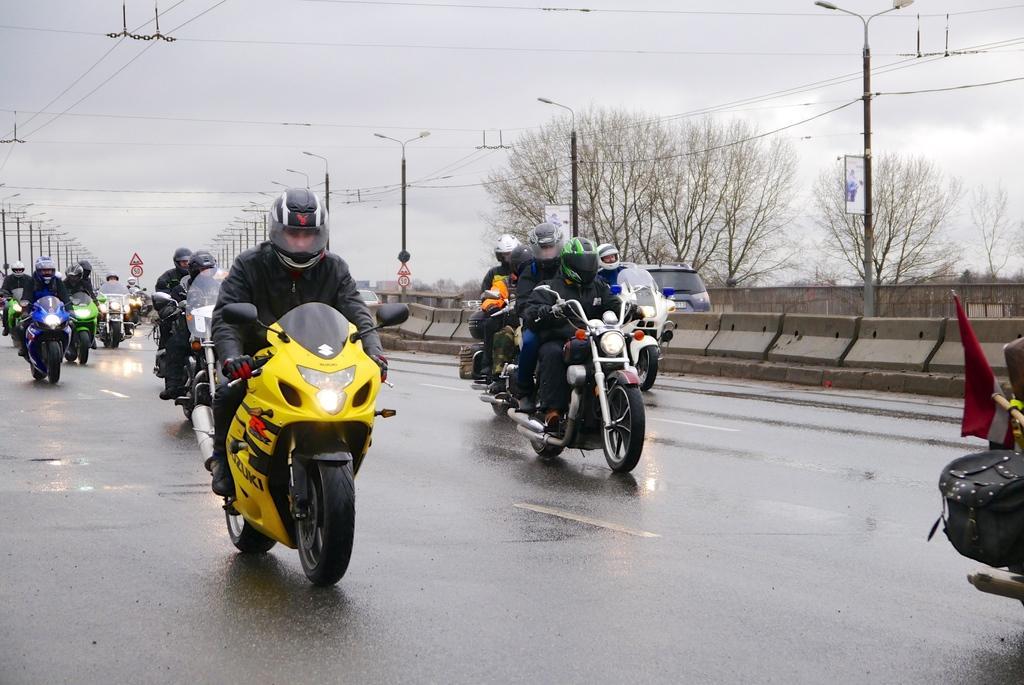How would you summarize this image in a sentence or two? In this image we can see a group of people wearing helmets riding the motor vehicles on the road. We can also see the divider, some vehicles, a fence, street poles, some wires, the sign boards, some trees and the sky which looks cloudy. 